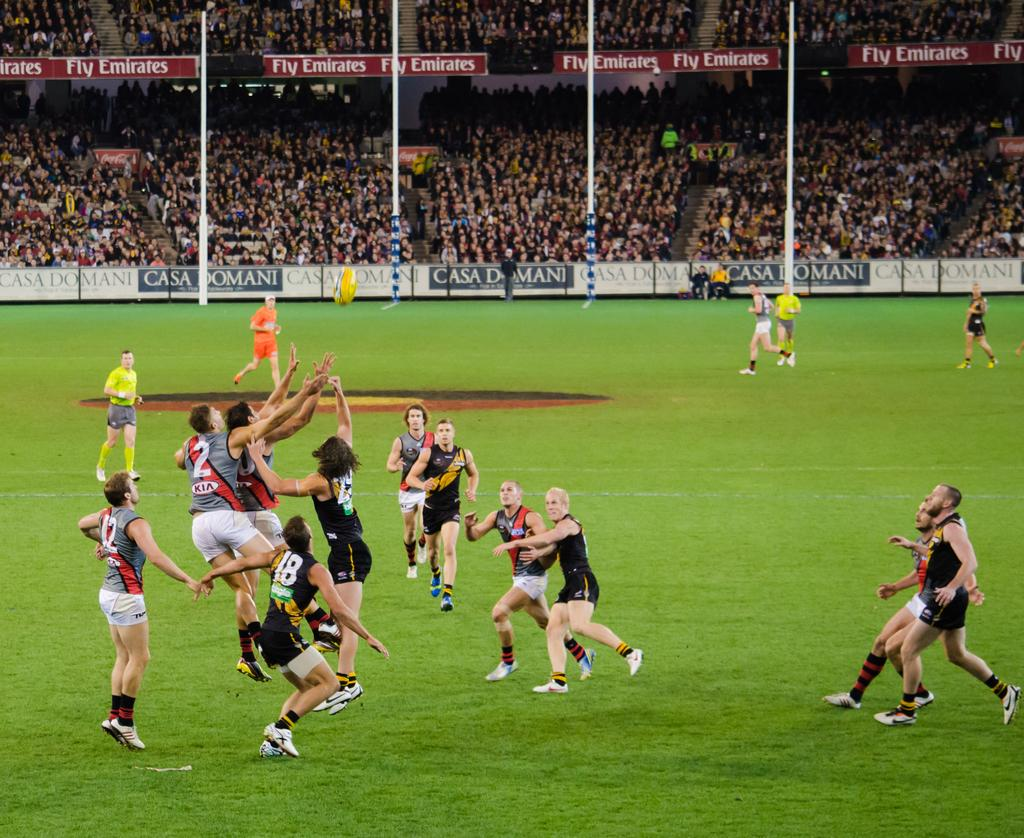<image>
Create a compact narrative representing the image presented. Players on the field playing rugby with a banner on the fence of Casa Domani. 